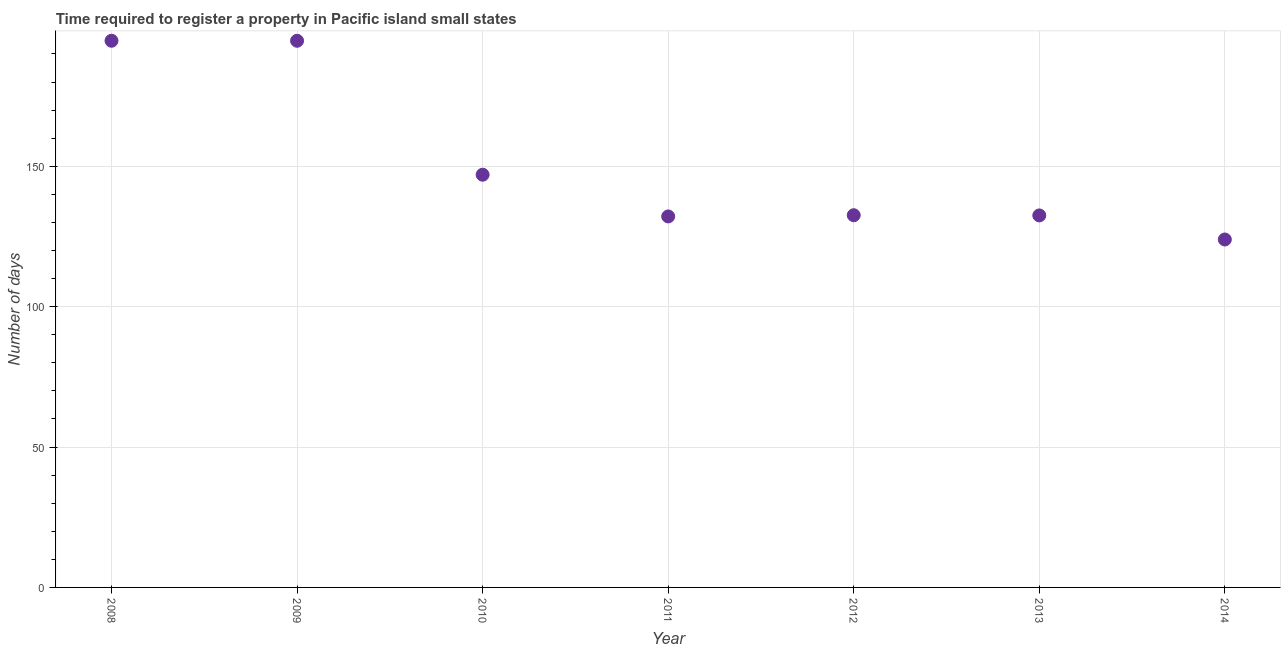What is the number of days required to register property in 2011?
Your answer should be very brief. 132.14. Across all years, what is the maximum number of days required to register property?
Your answer should be very brief. 194.71. Across all years, what is the minimum number of days required to register property?
Provide a succinct answer. 123.93. In which year was the number of days required to register property minimum?
Make the answer very short. 2014. What is the sum of the number of days required to register property?
Your answer should be very brief. 1057.57. What is the average number of days required to register property per year?
Offer a very short reply. 151.08. What is the median number of days required to register property?
Your answer should be very brief. 132.57. Do a majority of the years between 2009 and 2011 (inclusive) have number of days required to register property greater than 120 days?
Ensure brevity in your answer.  Yes. What is the ratio of the number of days required to register property in 2010 to that in 2011?
Provide a succinct answer. 1.11. Is the difference between the number of days required to register property in 2009 and 2011 greater than the difference between any two years?
Make the answer very short. No. What is the difference between the highest and the second highest number of days required to register property?
Your answer should be very brief. 0. Is the sum of the number of days required to register property in 2008 and 2009 greater than the maximum number of days required to register property across all years?
Provide a short and direct response. Yes. What is the difference between the highest and the lowest number of days required to register property?
Give a very brief answer. 70.79. Does the number of days required to register property monotonically increase over the years?
Your response must be concise. No. How many dotlines are there?
Give a very brief answer. 1. How many years are there in the graph?
Give a very brief answer. 7. What is the difference between two consecutive major ticks on the Y-axis?
Offer a terse response. 50. What is the title of the graph?
Provide a short and direct response. Time required to register a property in Pacific island small states. What is the label or title of the Y-axis?
Your answer should be very brief. Number of days. What is the Number of days in 2008?
Your answer should be compact. 194.71. What is the Number of days in 2009?
Give a very brief answer. 194.71. What is the Number of days in 2010?
Offer a terse response. 147. What is the Number of days in 2011?
Provide a succinct answer. 132.14. What is the Number of days in 2012?
Provide a short and direct response. 132.57. What is the Number of days in 2013?
Provide a short and direct response. 132.5. What is the Number of days in 2014?
Your answer should be compact. 123.93. What is the difference between the Number of days in 2008 and 2010?
Your response must be concise. 47.71. What is the difference between the Number of days in 2008 and 2011?
Offer a very short reply. 62.57. What is the difference between the Number of days in 2008 and 2012?
Provide a succinct answer. 62.14. What is the difference between the Number of days in 2008 and 2013?
Offer a terse response. 62.21. What is the difference between the Number of days in 2008 and 2014?
Provide a succinct answer. 70.79. What is the difference between the Number of days in 2009 and 2010?
Offer a terse response. 47.71. What is the difference between the Number of days in 2009 and 2011?
Provide a short and direct response. 62.57. What is the difference between the Number of days in 2009 and 2012?
Your answer should be very brief. 62.14. What is the difference between the Number of days in 2009 and 2013?
Ensure brevity in your answer.  62.21. What is the difference between the Number of days in 2009 and 2014?
Offer a very short reply. 70.79. What is the difference between the Number of days in 2010 and 2011?
Your answer should be compact. 14.86. What is the difference between the Number of days in 2010 and 2012?
Offer a terse response. 14.43. What is the difference between the Number of days in 2010 and 2014?
Your answer should be compact. 23.07. What is the difference between the Number of days in 2011 and 2012?
Ensure brevity in your answer.  -0.43. What is the difference between the Number of days in 2011 and 2013?
Provide a succinct answer. -0.36. What is the difference between the Number of days in 2011 and 2014?
Offer a terse response. 8.21. What is the difference between the Number of days in 2012 and 2013?
Offer a terse response. 0.07. What is the difference between the Number of days in 2012 and 2014?
Provide a short and direct response. 8.64. What is the difference between the Number of days in 2013 and 2014?
Your answer should be compact. 8.57. What is the ratio of the Number of days in 2008 to that in 2010?
Your answer should be compact. 1.32. What is the ratio of the Number of days in 2008 to that in 2011?
Provide a succinct answer. 1.47. What is the ratio of the Number of days in 2008 to that in 2012?
Give a very brief answer. 1.47. What is the ratio of the Number of days in 2008 to that in 2013?
Your response must be concise. 1.47. What is the ratio of the Number of days in 2008 to that in 2014?
Provide a short and direct response. 1.57. What is the ratio of the Number of days in 2009 to that in 2010?
Your response must be concise. 1.32. What is the ratio of the Number of days in 2009 to that in 2011?
Ensure brevity in your answer.  1.47. What is the ratio of the Number of days in 2009 to that in 2012?
Your answer should be very brief. 1.47. What is the ratio of the Number of days in 2009 to that in 2013?
Your response must be concise. 1.47. What is the ratio of the Number of days in 2009 to that in 2014?
Give a very brief answer. 1.57. What is the ratio of the Number of days in 2010 to that in 2011?
Your answer should be compact. 1.11. What is the ratio of the Number of days in 2010 to that in 2012?
Offer a terse response. 1.11. What is the ratio of the Number of days in 2010 to that in 2013?
Ensure brevity in your answer.  1.11. What is the ratio of the Number of days in 2010 to that in 2014?
Provide a succinct answer. 1.19. What is the ratio of the Number of days in 2011 to that in 2012?
Offer a very short reply. 1. What is the ratio of the Number of days in 2011 to that in 2014?
Keep it short and to the point. 1.07. What is the ratio of the Number of days in 2012 to that in 2014?
Offer a very short reply. 1.07. What is the ratio of the Number of days in 2013 to that in 2014?
Offer a very short reply. 1.07. 